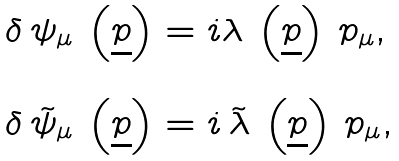<formula> <loc_0><loc_0><loc_500><loc_500>\begin{array} { l } \delta \, \psi _ { \mu } \, \left ( { \underline { p } } \right ) = i \lambda \, \left ( { \underline { p } } \right ) \, p _ { \mu } , \\ \\ \delta \, \tilde { \psi } _ { \mu } \, \left ( { \underline { p } } \right ) = i \, \tilde { \lambda } \, \left ( { \underline { p } } \right ) \, p _ { \mu } , \end{array}</formula> 